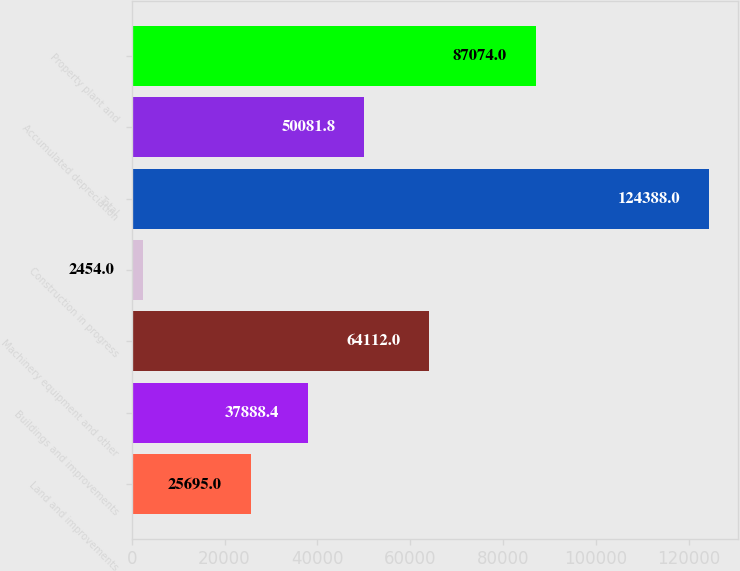Convert chart to OTSL. <chart><loc_0><loc_0><loc_500><loc_500><bar_chart><fcel>Land and improvements<fcel>Buildings and improvements<fcel>Machinery equipment and other<fcel>Construction in progress<fcel>Total<fcel>Accumulated depreciation<fcel>Property plant and<nl><fcel>25695<fcel>37888.4<fcel>64112<fcel>2454<fcel>124388<fcel>50081.8<fcel>87074<nl></chart> 